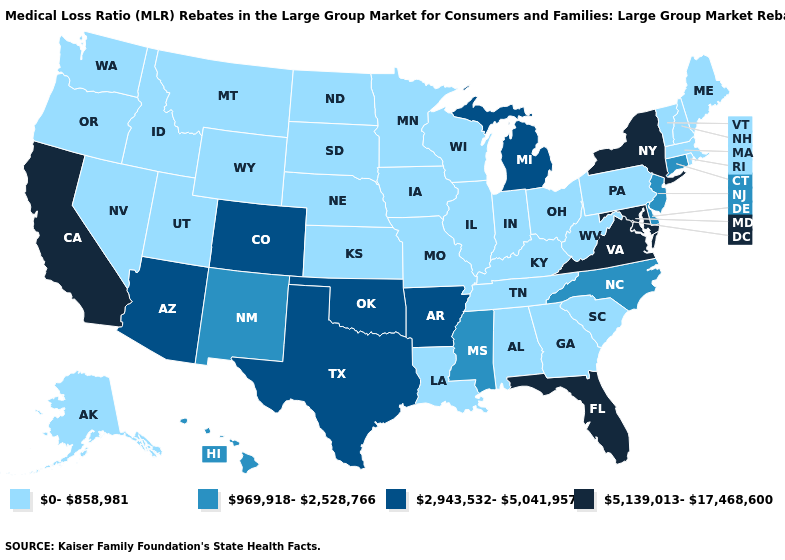What is the value of Kentucky?
Keep it brief. 0-858,981. Among the states that border Rhode Island , which have the lowest value?
Short answer required. Massachusetts. Which states hav the highest value in the South?
Concise answer only. Florida, Maryland, Virginia. Name the states that have a value in the range 2,943,532-5,041,957?
Answer briefly. Arizona, Arkansas, Colorado, Michigan, Oklahoma, Texas. Name the states that have a value in the range 5,139,013-17,468,600?
Give a very brief answer. California, Florida, Maryland, New York, Virginia. Name the states that have a value in the range 2,943,532-5,041,957?
Be succinct. Arizona, Arkansas, Colorado, Michigan, Oklahoma, Texas. Does Nebraska have the lowest value in the USA?
Concise answer only. Yes. Which states have the lowest value in the South?
Short answer required. Alabama, Georgia, Kentucky, Louisiana, South Carolina, Tennessee, West Virginia. Does Massachusetts have the lowest value in the Northeast?
Quick response, please. Yes. Which states have the lowest value in the South?
Concise answer only. Alabama, Georgia, Kentucky, Louisiana, South Carolina, Tennessee, West Virginia. Does California have the highest value in the West?
Answer briefly. Yes. Among the states that border Idaho , which have the highest value?
Concise answer only. Montana, Nevada, Oregon, Utah, Washington, Wyoming. Does Maryland have the highest value in the USA?
Answer briefly. Yes. Which states hav the highest value in the MidWest?
Be succinct. Michigan. 